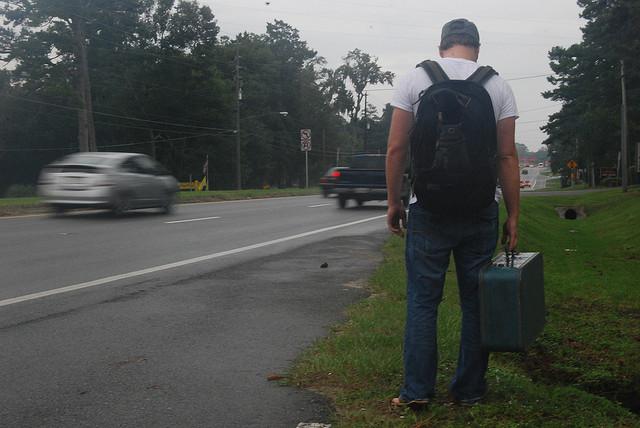Is the suitcase on wheels?
Keep it brief. No. What is the man carrying in his right hand?
Be succinct. Suitcase. Is there a sidewalk?
Keep it brief. No. Is this man hitchhiking?
Write a very short answer. Yes. Which hand holds the suitcase?
Be succinct. Right. What is the occupation of the man standing next to the vehicle?
Quick response, please. Traveler. Is the man skating?
Keep it brief. No. Overcast or sunny?
Keep it brief. Overcast. Is he skating?
Give a very brief answer. No. What is this gentlemen carrying?
Write a very short answer. Suitcase. 